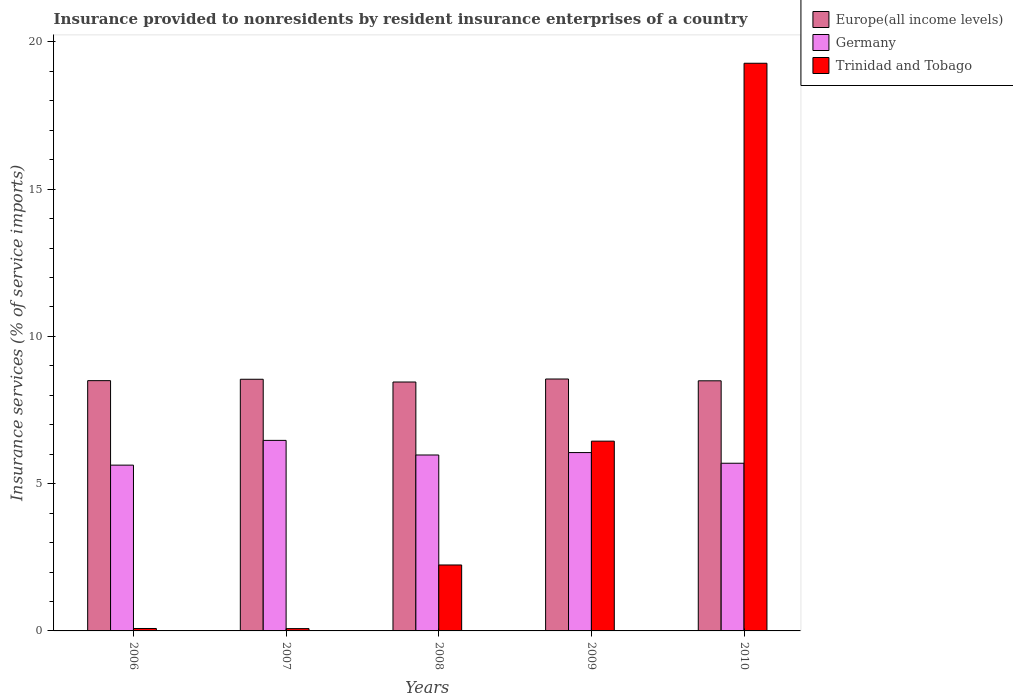How many different coloured bars are there?
Make the answer very short. 3. How many groups of bars are there?
Make the answer very short. 5. Are the number of bars on each tick of the X-axis equal?
Keep it short and to the point. Yes. What is the label of the 2nd group of bars from the left?
Provide a short and direct response. 2007. What is the insurance provided to nonresidents in Europe(all income levels) in 2006?
Provide a succinct answer. 8.5. Across all years, what is the maximum insurance provided to nonresidents in Germany?
Offer a terse response. 6.47. Across all years, what is the minimum insurance provided to nonresidents in Germany?
Give a very brief answer. 5.63. In which year was the insurance provided to nonresidents in Europe(all income levels) maximum?
Your answer should be very brief. 2009. In which year was the insurance provided to nonresidents in Europe(all income levels) minimum?
Offer a terse response. 2008. What is the total insurance provided to nonresidents in Europe(all income levels) in the graph?
Provide a succinct answer. 42.54. What is the difference between the insurance provided to nonresidents in Germany in 2006 and that in 2009?
Your response must be concise. -0.43. What is the difference between the insurance provided to nonresidents in Trinidad and Tobago in 2008 and the insurance provided to nonresidents in Germany in 2007?
Provide a succinct answer. -4.23. What is the average insurance provided to nonresidents in Trinidad and Tobago per year?
Offer a very short reply. 5.62. In the year 2009, what is the difference between the insurance provided to nonresidents in Europe(all income levels) and insurance provided to nonresidents in Trinidad and Tobago?
Give a very brief answer. 2.11. What is the ratio of the insurance provided to nonresidents in Europe(all income levels) in 2006 to that in 2008?
Your answer should be very brief. 1.01. What is the difference between the highest and the second highest insurance provided to nonresidents in Germany?
Your answer should be compact. 0.41. What is the difference between the highest and the lowest insurance provided to nonresidents in Europe(all income levels)?
Your answer should be very brief. 0.1. Is the sum of the insurance provided to nonresidents in Germany in 2007 and 2009 greater than the maximum insurance provided to nonresidents in Trinidad and Tobago across all years?
Provide a succinct answer. No. What does the 2nd bar from the left in 2010 represents?
Ensure brevity in your answer.  Germany. What does the 3rd bar from the right in 2006 represents?
Your answer should be very brief. Europe(all income levels). How many bars are there?
Your answer should be very brief. 15. How many years are there in the graph?
Provide a short and direct response. 5. What is the difference between two consecutive major ticks on the Y-axis?
Your response must be concise. 5. Are the values on the major ticks of Y-axis written in scientific E-notation?
Your answer should be compact. No. Does the graph contain any zero values?
Ensure brevity in your answer.  No. How many legend labels are there?
Your answer should be compact. 3. How are the legend labels stacked?
Make the answer very short. Vertical. What is the title of the graph?
Offer a very short reply. Insurance provided to nonresidents by resident insurance enterprises of a country. What is the label or title of the Y-axis?
Offer a terse response. Insurance services (% of service imports). What is the Insurance services (% of service imports) in Europe(all income levels) in 2006?
Your answer should be very brief. 8.5. What is the Insurance services (% of service imports) in Germany in 2006?
Ensure brevity in your answer.  5.63. What is the Insurance services (% of service imports) in Trinidad and Tobago in 2006?
Your answer should be compact. 0.08. What is the Insurance services (% of service imports) in Europe(all income levels) in 2007?
Your answer should be very brief. 8.55. What is the Insurance services (% of service imports) in Germany in 2007?
Make the answer very short. 6.47. What is the Insurance services (% of service imports) of Trinidad and Tobago in 2007?
Keep it short and to the point. 0.08. What is the Insurance services (% of service imports) of Europe(all income levels) in 2008?
Make the answer very short. 8.45. What is the Insurance services (% of service imports) of Germany in 2008?
Ensure brevity in your answer.  5.97. What is the Insurance services (% of service imports) in Trinidad and Tobago in 2008?
Make the answer very short. 2.24. What is the Insurance services (% of service imports) of Europe(all income levels) in 2009?
Give a very brief answer. 8.55. What is the Insurance services (% of service imports) of Germany in 2009?
Your answer should be very brief. 6.06. What is the Insurance services (% of service imports) of Trinidad and Tobago in 2009?
Provide a succinct answer. 6.44. What is the Insurance services (% of service imports) in Europe(all income levels) in 2010?
Provide a succinct answer. 8.49. What is the Insurance services (% of service imports) in Germany in 2010?
Offer a terse response. 5.69. What is the Insurance services (% of service imports) in Trinidad and Tobago in 2010?
Your answer should be very brief. 19.28. Across all years, what is the maximum Insurance services (% of service imports) of Europe(all income levels)?
Give a very brief answer. 8.55. Across all years, what is the maximum Insurance services (% of service imports) in Germany?
Your response must be concise. 6.47. Across all years, what is the maximum Insurance services (% of service imports) in Trinidad and Tobago?
Offer a very short reply. 19.28. Across all years, what is the minimum Insurance services (% of service imports) in Europe(all income levels)?
Offer a very short reply. 8.45. Across all years, what is the minimum Insurance services (% of service imports) in Germany?
Keep it short and to the point. 5.63. Across all years, what is the minimum Insurance services (% of service imports) of Trinidad and Tobago?
Your response must be concise. 0.08. What is the total Insurance services (% of service imports) in Europe(all income levels) in the graph?
Your response must be concise. 42.54. What is the total Insurance services (% of service imports) of Germany in the graph?
Your answer should be compact. 29.82. What is the total Insurance services (% of service imports) in Trinidad and Tobago in the graph?
Make the answer very short. 28.12. What is the difference between the Insurance services (% of service imports) in Europe(all income levels) in 2006 and that in 2007?
Ensure brevity in your answer.  -0.05. What is the difference between the Insurance services (% of service imports) in Germany in 2006 and that in 2007?
Your answer should be very brief. -0.84. What is the difference between the Insurance services (% of service imports) of Trinidad and Tobago in 2006 and that in 2007?
Provide a short and direct response. 0. What is the difference between the Insurance services (% of service imports) of Europe(all income levels) in 2006 and that in 2008?
Offer a very short reply. 0.05. What is the difference between the Insurance services (% of service imports) in Germany in 2006 and that in 2008?
Your answer should be very brief. -0.34. What is the difference between the Insurance services (% of service imports) in Trinidad and Tobago in 2006 and that in 2008?
Provide a succinct answer. -2.16. What is the difference between the Insurance services (% of service imports) of Europe(all income levels) in 2006 and that in 2009?
Your answer should be very brief. -0.06. What is the difference between the Insurance services (% of service imports) of Germany in 2006 and that in 2009?
Make the answer very short. -0.43. What is the difference between the Insurance services (% of service imports) in Trinidad and Tobago in 2006 and that in 2009?
Give a very brief answer. -6.36. What is the difference between the Insurance services (% of service imports) of Europe(all income levels) in 2006 and that in 2010?
Provide a succinct answer. 0.01. What is the difference between the Insurance services (% of service imports) of Germany in 2006 and that in 2010?
Ensure brevity in your answer.  -0.06. What is the difference between the Insurance services (% of service imports) of Trinidad and Tobago in 2006 and that in 2010?
Ensure brevity in your answer.  -19.19. What is the difference between the Insurance services (% of service imports) of Europe(all income levels) in 2007 and that in 2008?
Your answer should be compact. 0.09. What is the difference between the Insurance services (% of service imports) of Germany in 2007 and that in 2008?
Offer a terse response. 0.5. What is the difference between the Insurance services (% of service imports) in Trinidad and Tobago in 2007 and that in 2008?
Your response must be concise. -2.16. What is the difference between the Insurance services (% of service imports) in Europe(all income levels) in 2007 and that in 2009?
Keep it short and to the point. -0.01. What is the difference between the Insurance services (% of service imports) of Germany in 2007 and that in 2009?
Offer a very short reply. 0.41. What is the difference between the Insurance services (% of service imports) in Trinidad and Tobago in 2007 and that in 2009?
Your answer should be very brief. -6.37. What is the difference between the Insurance services (% of service imports) of Europe(all income levels) in 2007 and that in 2010?
Your response must be concise. 0.05. What is the difference between the Insurance services (% of service imports) in Germany in 2007 and that in 2010?
Offer a terse response. 0.78. What is the difference between the Insurance services (% of service imports) of Trinidad and Tobago in 2007 and that in 2010?
Keep it short and to the point. -19.2. What is the difference between the Insurance services (% of service imports) of Europe(all income levels) in 2008 and that in 2009?
Keep it short and to the point. -0.1. What is the difference between the Insurance services (% of service imports) in Germany in 2008 and that in 2009?
Offer a terse response. -0.08. What is the difference between the Insurance services (% of service imports) of Trinidad and Tobago in 2008 and that in 2009?
Keep it short and to the point. -4.2. What is the difference between the Insurance services (% of service imports) of Europe(all income levels) in 2008 and that in 2010?
Your answer should be compact. -0.04. What is the difference between the Insurance services (% of service imports) of Germany in 2008 and that in 2010?
Make the answer very short. 0.28. What is the difference between the Insurance services (% of service imports) of Trinidad and Tobago in 2008 and that in 2010?
Give a very brief answer. -17.04. What is the difference between the Insurance services (% of service imports) of Europe(all income levels) in 2009 and that in 2010?
Offer a terse response. 0.06. What is the difference between the Insurance services (% of service imports) of Germany in 2009 and that in 2010?
Your answer should be very brief. 0.36. What is the difference between the Insurance services (% of service imports) in Trinidad and Tobago in 2009 and that in 2010?
Give a very brief answer. -12.83. What is the difference between the Insurance services (% of service imports) in Europe(all income levels) in 2006 and the Insurance services (% of service imports) in Germany in 2007?
Offer a very short reply. 2.03. What is the difference between the Insurance services (% of service imports) of Europe(all income levels) in 2006 and the Insurance services (% of service imports) of Trinidad and Tobago in 2007?
Provide a succinct answer. 8.42. What is the difference between the Insurance services (% of service imports) in Germany in 2006 and the Insurance services (% of service imports) in Trinidad and Tobago in 2007?
Your answer should be very brief. 5.55. What is the difference between the Insurance services (% of service imports) of Europe(all income levels) in 2006 and the Insurance services (% of service imports) of Germany in 2008?
Your answer should be compact. 2.52. What is the difference between the Insurance services (% of service imports) of Europe(all income levels) in 2006 and the Insurance services (% of service imports) of Trinidad and Tobago in 2008?
Offer a very short reply. 6.26. What is the difference between the Insurance services (% of service imports) of Germany in 2006 and the Insurance services (% of service imports) of Trinidad and Tobago in 2008?
Your answer should be very brief. 3.39. What is the difference between the Insurance services (% of service imports) in Europe(all income levels) in 2006 and the Insurance services (% of service imports) in Germany in 2009?
Provide a short and direct response. 2.44. What is the difference between the Insurance services (% of service imports) in Europe(all income levels) in 2006 and the Insurance services (% of service imports) in Trinidad and Tobago in 2009?
Your answer should be very brief. 2.05. What is the difference between the Insurance services (% of service imports) of Germany in 2006 and the Insurance services (% of service imports) of Trinidad and Tobago in 2009?
Provide a short and direct response. -0.81. What is the difference between the Insurance services (% of service imports) in Europe(all income levels) in 2006 and the Insurance services (% of service imports) in Germany in 2010?
Your answer should be very brief. 2.8. What is the difference between the Insurance services (% of service imports) in Europe(all income levels) in 2006 and the Insurance services (% of service imports) in Trinidad and Tobago in 2010?
Provide a short and direct response. -10.78. What is the difference between the Insurance services (% of service imports) of Germany in 2006 and the Insurance services (% of service imports) of Trinidad and Tobago in 2010?
Offer a very short reply. -13.65. What is the difference between the Insurance services (% of service imports) in Europe(all income levels) in 2007 and the Insurance services (% of service imports) in Germany in 2008?
Make the answer very short. 2.57. What is the difference between the Insurance services (% of service imports) of Europe(all income levels) in 2007 and the Insurance services (% of service imports) of Trinidad and Tobago in 2008?
Ensure brevity in your answer.  6.31. What is the difference between the Insurance services (% of service imports) of Germany in 2007 and the Insurance services (% of service imports) of Trinidad and Tobago in 2008?
Offer a terse response. 4.23. What is the difference between the Insurance services (% of service imports) in Europe(all income levels) in 2007 and the Insurance services (% of service imports) in Germany in 2009?
Your response must be concise. 2.49. What is the difference between the Insurance services (% of service imports) of Europe(all income levels) in 2007 and the Insurance services (% of service imports) of Trinidad and Tobago in 2009?
Make the answer very short. 2.1. What is the difference between the Insurance services (% of service imports) of Germany in 2007 and the Insurance services (% of service imports) of Trinidad and Tobago in 2009?
Provide a short and direct response. 0.03. What is the difference between the Insurance services (% of service imports) in Europe(all income levels) in 2007 and the Insurance services (% of service imports) in Germany in 2010?
Keep it short and to the point. 2.85. What is the difference between the Insurance services (% of service imports) of Europe(all income levels) in 2007 and the Insurance services (% of service imports) of Trinidad and Tobago in 2010?
Your answer should be compact. -10.73. What is the difference between the Insurance services (% of service imports) in Germany in 2007 and the Insurance services (% of service imports) in Trinidad and Tobago in 2010?
Your answer should be very brief. -12.81. What is the difference between the Insurance services (% of service imports) of Europe(all income levels) in 2008 and the Insurance services (% of service imports) of Germany in 2009?
Provide a short and direct response. 2.4. What is the difference between the Insurance services (% of service imports) in Europe(all income levels) in 2008 and the Insurance services (% of service imports) in Trinidad and Tobago in 2009?
Offer a terse response. 2.01. What is the difference between the Insurance services (% of service imports) of Germany in 2008 and the Insurance services (% of service imports) of Trinidad and Tobago in 2009?
Give a very brief answer. -0.47. What is the difference between the Insurance services (% of service imports) of Europe(all income levels) in 2008 and the Insurance services (% of service imports) of Germany in 2010?
Give a very brief answer. 2.76. What is the difference between the Insurance services (% of service imports) of Europe(all income levels) in 2008 and the Insurance services (% of service imports) of Trinidad and Tobago in 2010?
Ensure brevity in your answer.  -10.82. What is the difference between the Insurance services (% of service imports) of Germany in 2008 and the Insurance services (% of service imports) of Trinidad and Tobago in 2010?
Keep it short and to the point. -13.3. What is the difference between the Insurance services (% of service imports) of Europe(all income levels) in 2009 and the Insurance services (% of service imports) of Germany in 2010?
Provide a short and direct response. 2.86. What is the difference between the Insurance services (% of service imports) in Europe(all income levels) in 2009 and the Insurance services (% of service imports) in Trinidad and Tobago in 2010?
Your answer should be very brief. -10.72. What is the difference between the Insurance services (% of service imports) of Germany in 2009 and the Insurance services (% of service imports) of Trinidad and Tobago in 2010?
Keep it short and to the point. -13.22. What is the average Insurance services (% of service imports) in Europe(all income levels) per year?
Ensure brevity in your answer.  8.51. What is the average Insurance services (% of service imports) of Germany per year?
Your answer should be compact. 5.96. What is the average Insurance services (% of service imports) of Trinidad and Tobago per year?
Offer a terse response. 5.62. In the year 2006, what is the difference between the Insurance services (% of service imports) of Europe(all income levels) and Insurance services (% of service imports) of Germany?
Offer a terse response. 2.87. In the year 2006, what is the difference between the Insurance services (% of service imports) of Europe(all income levels) and Insurance services (% of service imports) of Trinidad and Tobago?
Give a very brief answer. 8.42. In the year 2006, what is the difference between the Insurance services (% of service imports) of Germany and Insurance services (% of service imports) of Trinidad and Tobago?
Keep it short and to the point. 5.55. In the year 2007, what is the difference between the Insurance services (% of service imports) of Europe(all income levels) and Insurance services (% of service imports) of Germany?
Give a very brief answer. 2.08. In the year 2007, what is the difference between the Insurance services (% of service imports) in Europe(all income levels) and Insurance services (% of service imports) in Trinidad and Tobago?
Your answer should be compact. 8.47. In the year 2007, what is the difference between the Insurance services (% of service imports) in Germany and Insurance services (% of service imports) in Trinidad and Tobago?
Your answer should be compact. 6.39. In the year 2008, what is the difference between the Insurance services (% of service imports) in Europe(all income levels) and Insurance services (% of service imports) in Germany?
Your answer should be very brief. 2.48. In the year 2008, what is the difference between the Insurance services (% of service imports) of Europe(all income levels) and Insurance services (% of service imports) of Trinidad and Tobago?
Keep it short and to the point. 6.21. In the year 2008, what is the difference between the Insurance services (% of service imports) of Germany and Insurance services (% of service imports) of Trinidad and Tobago?
Your response must be concise. 3.73. In the year 2009, what is the difference between the Insurance services (% of service imports) of Europe(all income levels) and Insurance services (% of service imports) of Germany?
Your answer should be very brief. 2.5. In the year 2009, what is the difference between the Insurance services (% of service imports) of Europe(all income levels) and Insurance services (% of service imports) of Trinidad and Tobago?
Your answer should be compact. 2.11. In the year 2009, what is the difference between the Insurance services (% of service imports) in Germany and Insurance services (% of service imports) in Trinidad and Tobago?
Offer a terse response. -0.39. In the year 2010, what is the difference between the Insurance services (% of service imports) in Europe(all income levels) and Insurance services (% of service imports) in Germany?
Offer a very short reply. 2.8. In the year 2010, what is the difference between the Insurance services (% of service imports) of Europe(all income levels) and Insurance services (% of service imports) of Trinidad and Tobago?
Offer a very short reply. -10.78. In the year 2010, what is the difference between the Insurance services (% of service imports) in Germany and Insurance services (% of service imports) in Trinidad and Tobago?
Make the answer very short. -13.58. What is the ratio of the Insurance services (% of service imports) in Germany in 2006 to that in 2007?
Give a very brief answer. 0.87. What is the ratio of the Insurance services (% of service imports) of Trinidad and Tobago in 2006 to that in 2007?
Provide a succinct answer. 1.06. What is the ratio of the Insurance services (% of service imports) in Europe(all income levels) in 2006 to that in 2008?
Your answer should be compact. 1.01. What is the ratio of the Insurance services (% of service imports) of Germany in 2006 to that in 2008?
Provide a succinct answer. 0.94. What is the ratio of the Insurance services (% of service imports) of Trinidad and Tobago in 2006 to that in 2008?
Your answer should be very brief. 0.04. What is the ratio of the Insurance services (% of service imports) of Europe(all income levels) in 2006 to that in 2009?
Ensure brevity in your answer.  0.99. What is the ratio of the Insurance services (% of service imports) in Germany in 2006 to that in 2009?
Offer a very short reply. 0.93. What is the ratio of the Insurance services (% of service imports) in Trinidad and Tobago in 2006 to that in 2009?
Offer a terse response. 0.01. What is the ratio of the Insurance services (% of service imports) in Trinidad and Tobago in 2006 to that in 2010?
Your response must be concise. 0. What is the ratio of the Insurance services (% of service imports) of Europe(all income levels) in 2007 to that in 2008?
Make the answer very short. 1.01. What is the ratio of the Insurance services (% of service imports) in Germany in 2007 to that in 2008?
Offer a terse response. 1.08. What is the ratio of the Insurance services (% of service imports) in Trinidad and Tobago in 2007 to that in 2008?
Ensure brevity in your answer.  0.03. What is the ratio of the Insurance services (% of service imports) of Germany in 2007 to that in 2009?
Your answer should be compact. 1.07. What is the ratio of the Insurance services (% of service imports) of Trinidad and Tobago in 2007 to that in 2009?
Give a very brief answer. 0.01. What is the ratio of the Insurance services (% of service imports) in Europe(all income levels) in 2007 to that in 2010?
Ensure brevity in your answer.  1.01. What is the ratio of the Insurance services (% of service imports) of Germany in 2007 to that in 2010?
Your answer should be very brief. 1.14. What is the ratio of the Insurance services (% of service imports) of Trinidad and Tobago in 2007 to that in 2010?
Offer a terse response. 0. What is the ratio of the Insurance services (% of service imports) of Germany in 2008 to that in 2009?
Ensure brevity in your answer.  0.99. What is the ratio of the Insurance services (% of service imports) of Trinidad and Tobago in 2008 to that in 2009?
Your answer should be very brief. 0.35. What is the ratio of the Insurance services (% of service imports) in Europe(all income levels) in 2008 to that in 2010?
Your response must be concise. 1. What is the ratio of the Insurance services (% of service imports) of Germany in 2008 to that in 2010?
Your response must be concise. 1.05. What is the ratio of the Insurance services (% of service imports) of Trinidad and Tobago in 2008 to that in 2010?
Offer a terse response. 0.12. What is the ratio of the Insurance services (% of service imports) of Germany in 2009 to that in 2010?
Offer a very short reply. 1.06. What is the ratio of the Insurance services (% of service imports) of Trinidad and Tobago in 2009 to that in 2010?
Provide a succinct answer. 0.33. What is the difference between the highest and the second highest Insurance services (% of service imports) in Europe(all income levels)?
Your answer should be very brief. 0.01. What is the difference between the highest and the second highest Insurance services (% of service imports) of Germany?
Keep it short and to the point. 0.41. What is the difference between the highest and the second highest Insurance services (% of service imports) of Trinidad and Tobago?
Your answer should be compact. 12.83. What is the difference between the highest and the lowest Insurance services (% of service imports) of Europe(all income levels)?
Your answer should be very brief. 0.1. What is the difference between the highest and the lowest Insurance services (% of service imports) in Germany?
Offer a very short reply. 0.84. What is the difference between the highest and the lowest Insurance services (% of service imports) of Trinidad and Tobago?
Make the answer very short. 19.2. 